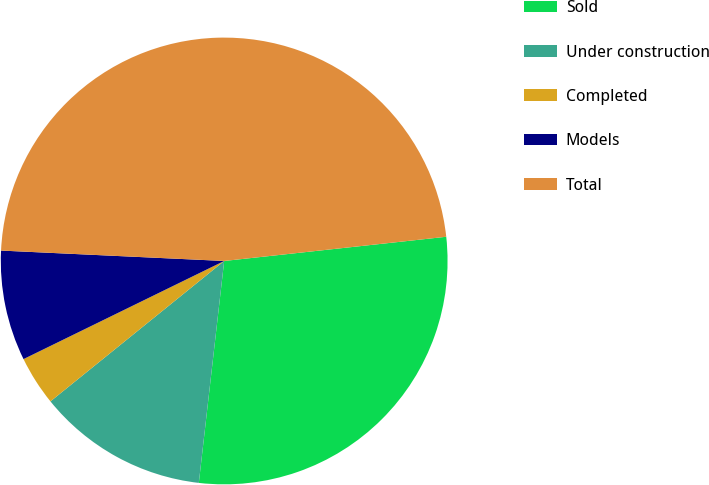<chart> <loc_0><loc_0><loc_500><loc_500><pie_chart><fcel>Sold<fcel>Under construction<fcel>Completed<fcel>Models<fcel>Total<nl><fcel>28.54%<fcel>12.37%<fcel>3.58%<fcel>7.98%<fcel>47.53%<nl></chart> 